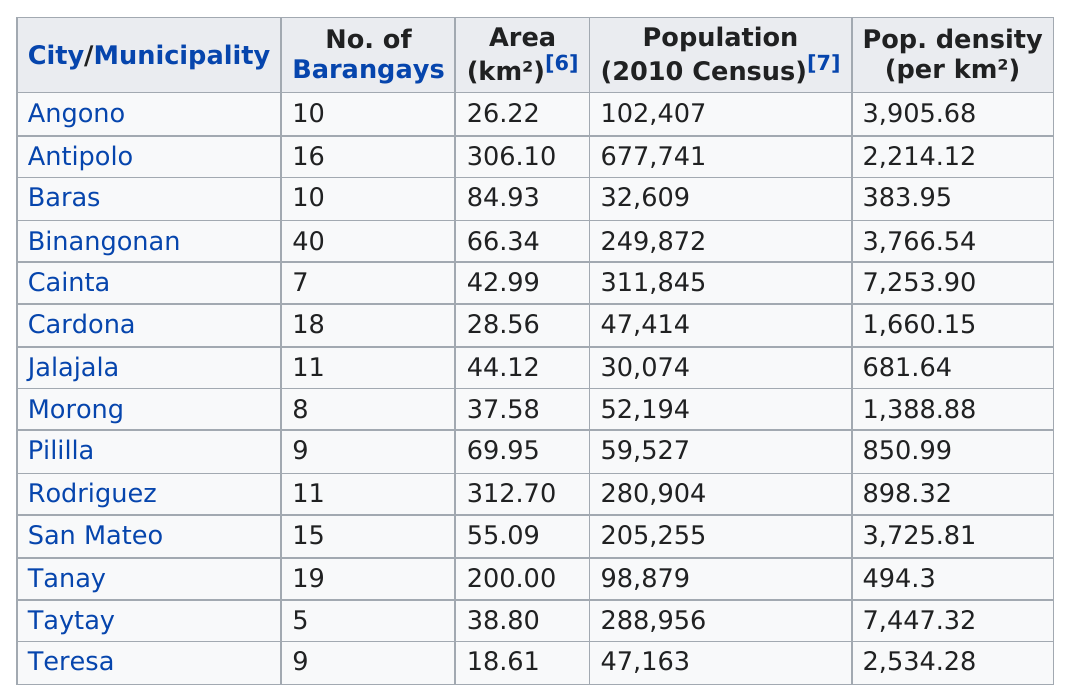Point out several critical features in this image. Taytay is a city that has only five barangays. There are 14 cities in the province of Rizal. Rodriguez is the largest city in Rizal in terms of area. There are 40 barangays in Binangonan. Numerous cities have a minimum of 10 barangays. 